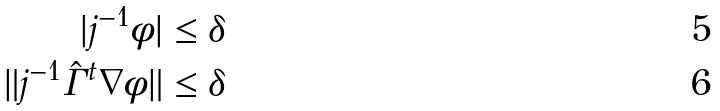Convert formula to latex. <formula><loc_0><loc_0><loc_500><loc_500>| j ^ { - 1 } \phi | & \leq \delta \\ \| j ^ { - 1 } \hat { \Gamma } ^ { t } \nabla \phi \| & \leq \delta</formula> 